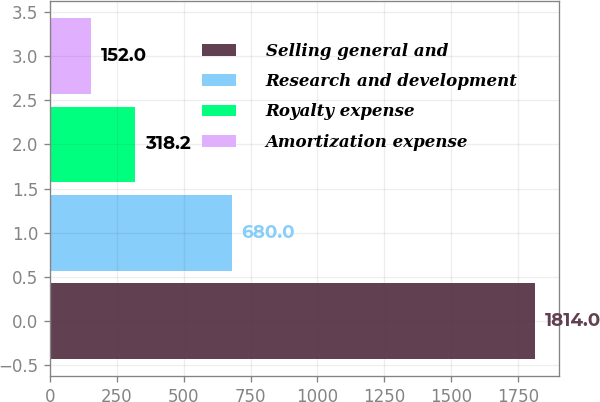Convert chart to OTSL. <chart><loc_0><loc_0><loc_500><loc_500><bar_chart><fcel>Selling general and<fcel>Research and development<fcel>Royalty expense<fcel>Amortization expense<nl><fcel>1814<fcel>680<fcel>318.2<fcel>152<nl></chart> 